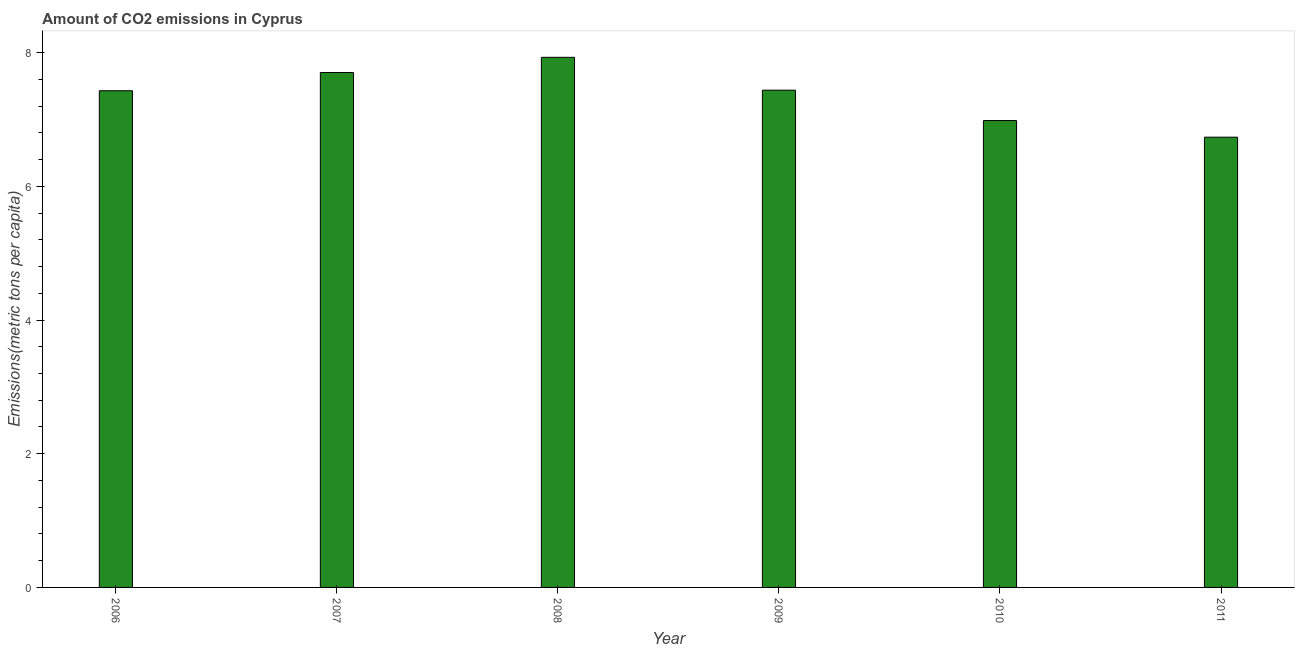Does the graph contain any zero values?
Your response must be concise. No. Does the graph contain grids?
Ensure brevity in your answer.  No. What is the title of the graph?
Give a very brief answer. Amount of CO2 emissions in Cyprus. What is the label or title of the X-axis?
Your answer should be very brief. Year. What is the label or title of the Y-axis?
Offer a terse response. Emissions(metric tons per capita). What is the amount of co2 emissions in 2007?
Your response must be concise. 7.7. Across all years, what is the maximum amount of co2 emissions?
Offer a terse response. 7.93. Across all years, what is the minimum amount of co2 emissions?
Your answer should be compact. 6.74. In which year was the amount of co2 emissions maximum?
Your answer should be compact. 2008. What is the sum of the amount of co2 emissions?
Offer a very short reply. 44.22. What is the difference between the amount of co2 emissions in 2006 and 2009?
Make the answer very short. -0.01. What is the average amount of co2 emissions per year?
Your answer should be very brief. 7.37. What is the median amount of co2 emissions?
Your response must be concise. 7.43. In how many years, is the amount of co2 emissions greater than 4.4 metric tons per capita?
Offer a very short reply. 6. Do a majority of the years between 2008 and 2007 (inclusive) have amount of co2 emissions greater than 0.8 metric tons per capita?
Give a very brief answer. No. What is the ratio of the amount of co2 emissions in 2008 to that in 2011?
Your answer should be very brief. 1.18. Is the amount of co2 emissions in 2006 less than that in 2011?
Your answer should be very brief. No. What is the difference between the highest and the second highest amount of co2 emissions?
Keep it short and to the point. 0.23. What is the difference between the highest and the lowest amount of co2 emissions?
Provide a short and direct response. 1.19. How many years are there in the graph?
Ensure brevity in your answer.  6. What is the difference between two consecutive major ticks on the Y-axis?
Provide a succinct answer. 2. Are the values on the major ticks of Y-axis written in scientific E-notation?
Keep it short and to the point. No. What is the Emissions(metric tons per capita) in 2006?
Offer a terse response. 7.43. What is the Emissions(metric tons per capita) in 2007?
Ensure brevity in your answer.  7.7. What is the Emissions(metric tons per capita) in 2008?
Offer a very short reply. 7.93. What is the Emissions(metric tons per capita) of 2009?
Ensure brevity in your answer.  7.44. What is the Emissions(metric tons per capita) in 2010?
Your answer should be compact. 6.98. What is the Emissions(metric tons per capita) of 2011?
Ensure brevity in your answer.  6.74. What is the difference between the Emissions(metric tons per capita) in 2006 and 2007?
Make the answer very short. -0.27. What is the difference between the Emissions(metric tons per capita) in 2006 and 2008?
Give a very brief answer. -0.5. What is the difference between the Emissions(metric tons per capita) in 2006 and 2009?
Your response must be concise. -0.01. What is the difference between the Emissions(metric tons per capita) in 2006 and 2010?
Make the answer very short. 0.45. What is the difference between the Emissions(metric tons per capita) in 2006 and 2011?
Offer a very short reply. 0.69. What is the difference between the Emissions(metric tons per capita) in 2007 and 2008?
Your response must be concise. -0.23. What is the difference between the Emissions(metric tons per capita) in 2007 and 2009?
Ensure brevity in your answer.  0.26. What is the difference between the Emissions(metric tons per capita) in 2007 and 2010?
Keep it short and to the point. 0.72. What is the difference between the Emissions(metric tons per capita) in 2007 and 2011?
Provide a succinct answer. 0.97. What is the difference between the Emissions(metric tons per capita) in 2008 and 2009?
Offer a very short reply. 0.49. What is the difference between the Emissions(metric tons per capita) in 2008 and 2010?
Your response must be concise. 0.95. What is the difference between the Emissions(metric tons per capita) in 2008 and 2011?
Give a very brief answer. 1.19. What is the difference between the Emissions(metric tons per capita) in 2009 and 2010?
Your response must be concise. 0.45. What is the difference between the Emissions(metric tons per capita) in 2009 and 2011?
Offer a terse response. 0.7. What is the difference between the Emissions(metric tons per capita) in 2010 and 2011?
Keep it short and to the point. 0.25. What is the ratio of the Emissions(metric tons per capita) in 2006 to that in 2008?
Give a very brief answer. 0.94. What is the ratio of the Emissions(metric tons per capita) in 2006 to that in 2009?
Ensure brevity in your answer.  1. What is the ratio of the Emissions(metric tons per capita) in 2006 to that in 2010?
Ensure brevity in your answer.  1.06. What is the ratio of the Emissions(metric tons per capita) in 2006 to that in 2011?
Your response must be concise. 1.1. What is the ratio of the Emissions(metric tons per capita) in 2007 to that in 2009?
Ensure brevity in your answer.  1.04. What is the ratio of the Emissions(metric tons per capita) in 2007 to that in 2010?
Your answer should be very brief. 1.1. What is the ratio of the Emissions(metric tons per capita) in 2007 to that in 2011?
Make the answer very short. 1.14. What is the ratio of the Emissions(metric tons per capita) in 2008 to that in 2009?
Your answer should be compact. 1.07. What is the ratio of the Emissions(metric tons per capita) in 2008 to that in 2010?
Ensure brevity in your answer.  1.14. What is the ratio of the Emissions(metric tons per capita) in 2008 to that in 2011?
Your answer should be compact. 1.18. What is the ratio of the Emissions(metric tons per capita) in 2009 to that in 2010?
Keep it short and to the point. 1.06. What is the ratio of the Emissions(metric tons per capita) in 2009 to that in 2011?
Your answer should be very brief. 1.1. What is the ratio of the Emissions(metric tons per capita) in 2010 to that in 2011?
Ensure brevity in your answer.  1.04. 